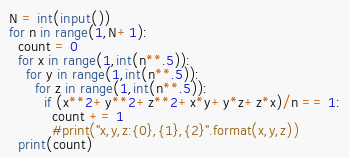Convert code to text. <code><loc_0><loc_0><loc_500><loc_500><_Python_>N = int(input())
for n in range(1,N+1):
  count = 0
  for x in range(1,int(n**.5)):
    for y in range(1,int(n**.5)):
      for z in range(1,int(n**.5)):
        if (x**2+y**2+z**2+x*y+y*z+z*x)/n == 1:
          count += 1
          #print("x,y,z:{0},{1},{2}".format(x,y,z))
  print(count)</code> 